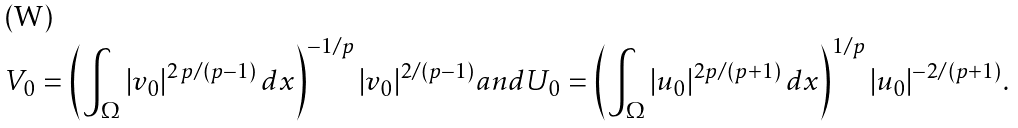<formula> <loc_0><loc_0><loc_500><loc_500>V _ { 0 } = \left ( \int _ { \Omega } | v _ { 0 } | ^ { 2 \, p / ( p - 1 ) } \, d x \right ) ^ { - 1 / p } | v _ { 0 } | ^ { 2 / ( p - 1 ) } a n d U _ { 0 } = \left ( \int _ { \Omega } | u _ { 0 } | ^ { 2 p / ( p + 1 ) } \, d x \right ) ^ { 1 / p } | u _ { 0 } | ^ { - 2 / ( p + 1 ) } .</formula> 